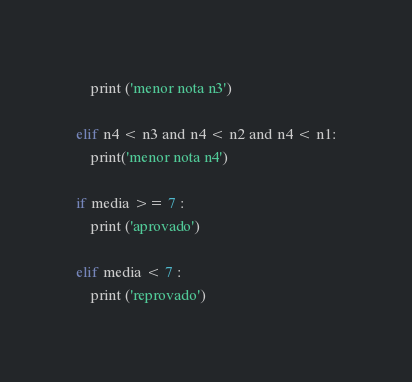<code> <loc_0><loc_0><loc_500><loc_500><_Python_>    print ('menor nota n3')

elif n4 < n3 and n4 < n2 and n4 < n1:
    print('menor nota n4')

if media >= 7 :
    print ('aprovado')

elif media < 7 :
    print ('reprovado')

</code> 